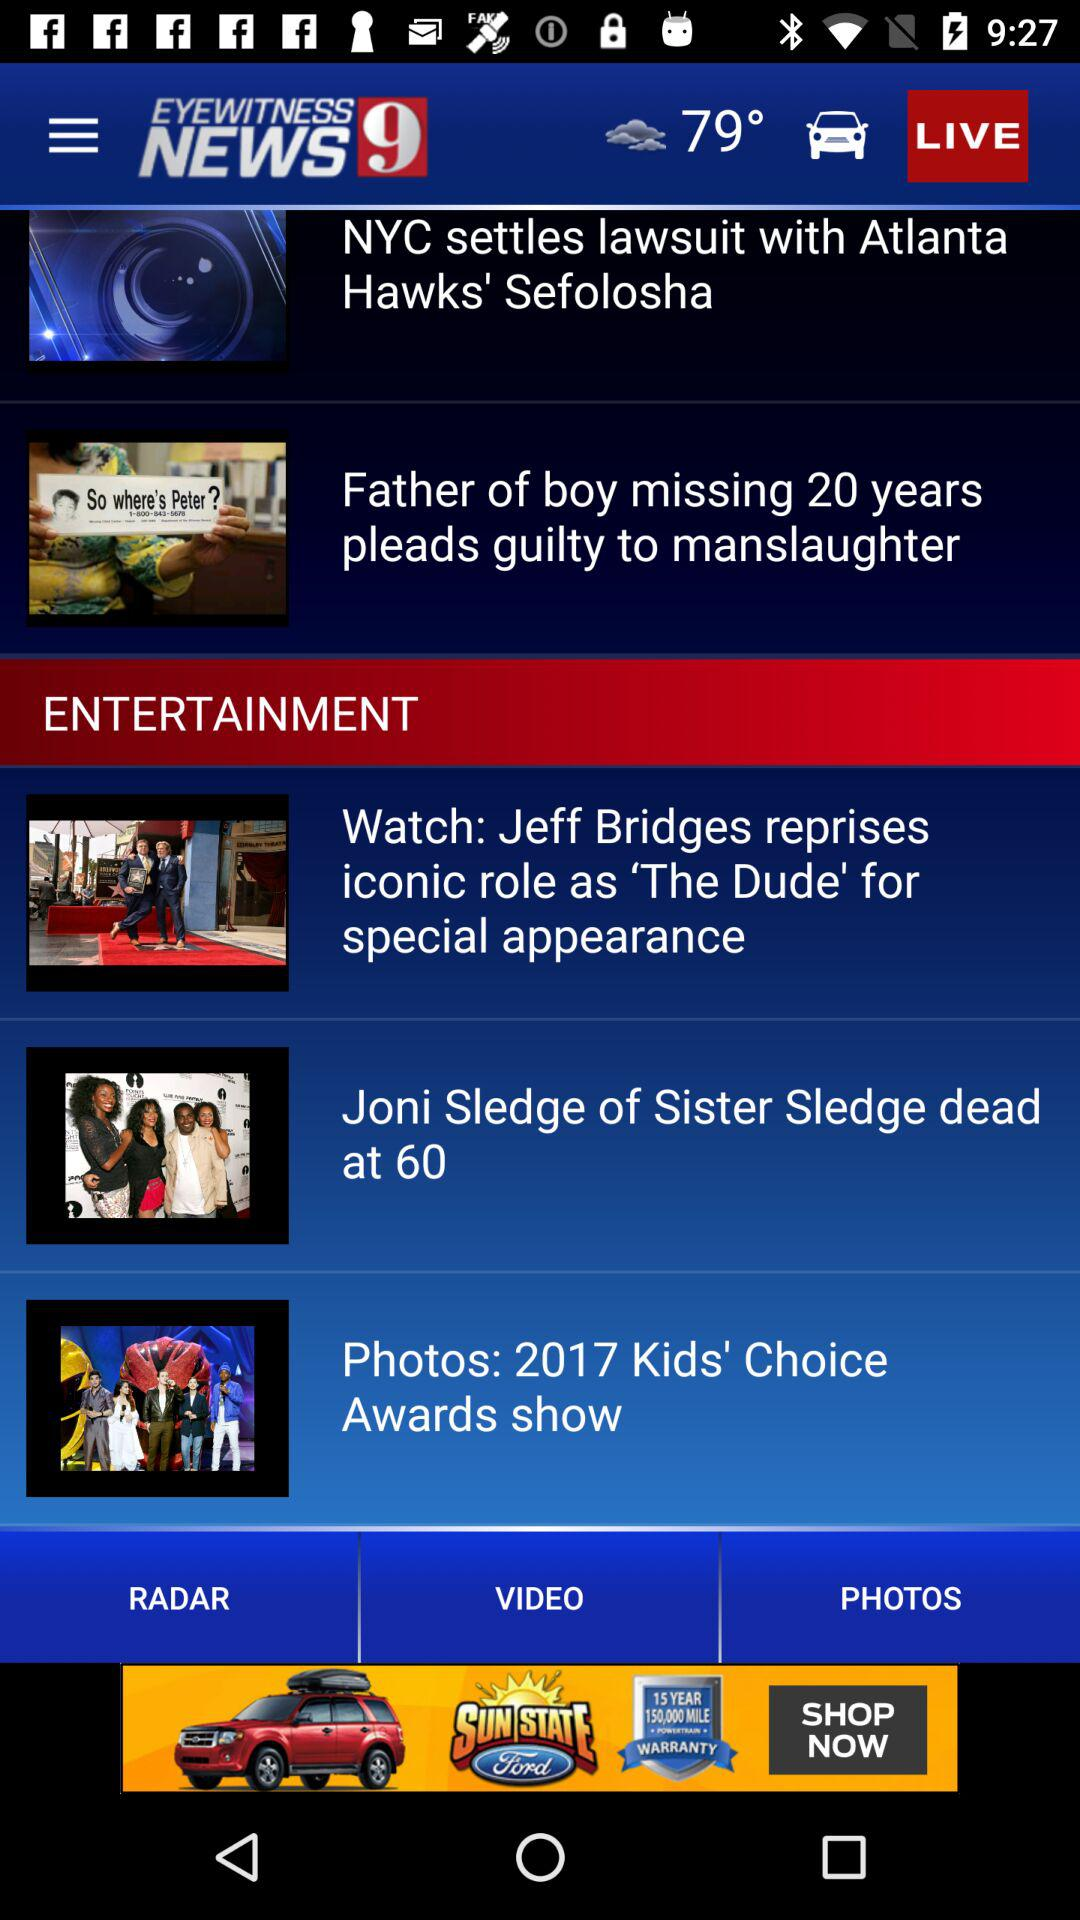What is the app name? The app name is "EYEWITNESS NEWS 9". 